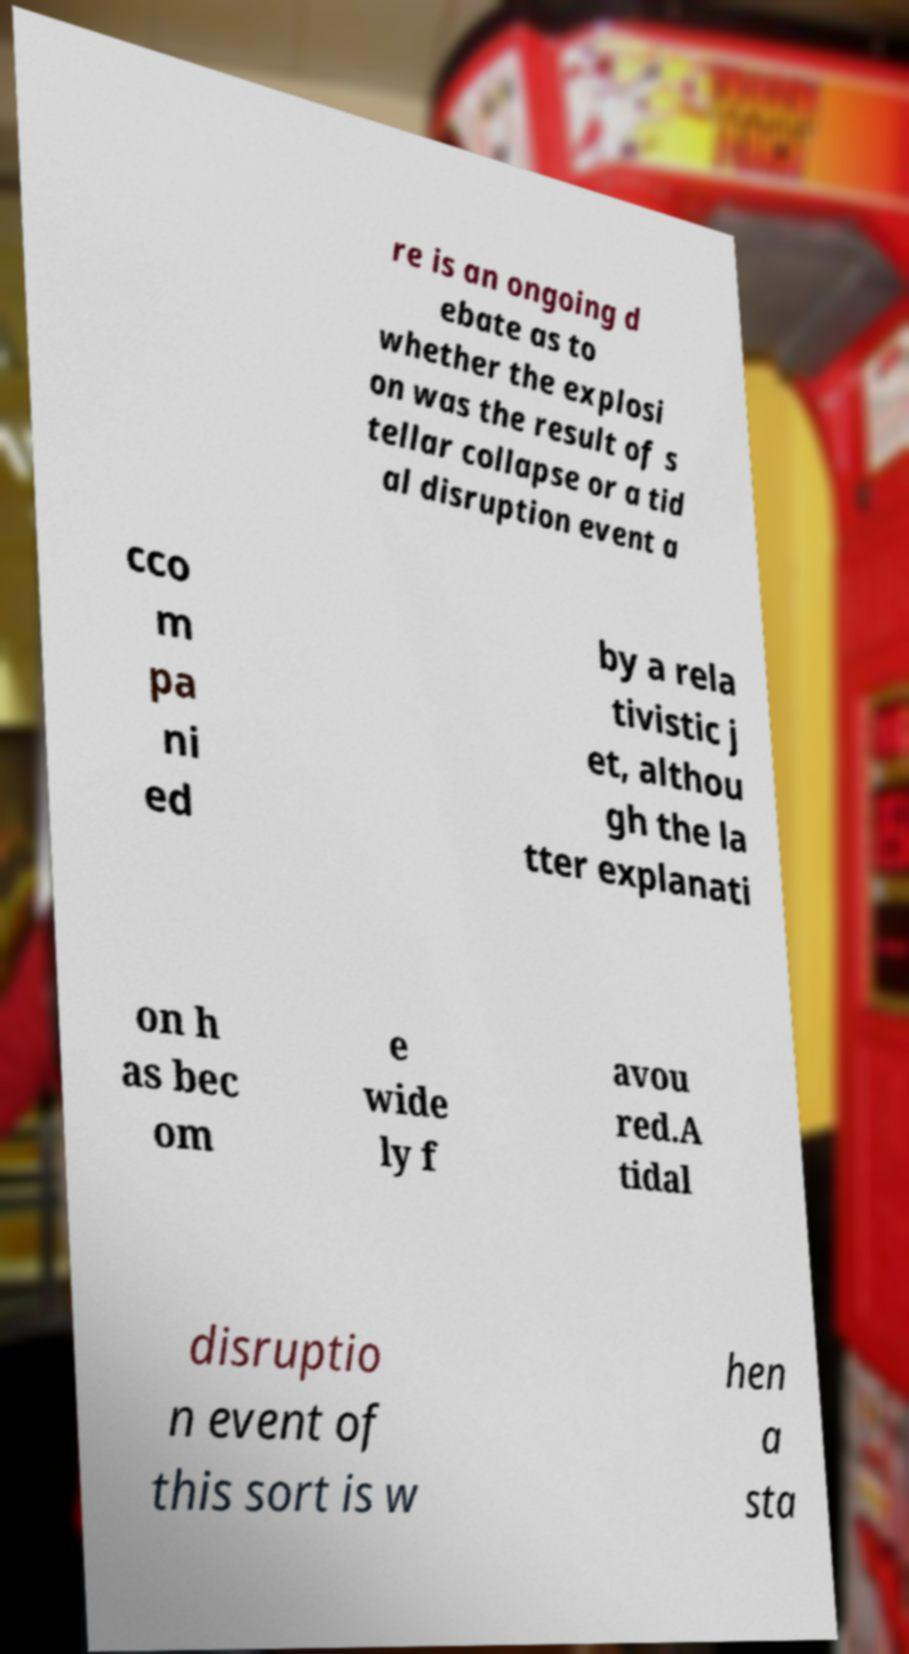Could you assist in decoding the text presented in this image and type it out clearly? re is an ongoing d ebate as to whether the explosi on was the result of s tellar collapse or a tid al disruption event a cco m pa ni ed by a rela tivistic j et, althou gh the la tter explanati on h as bec om e wide ly f avou red.A tidal disruptio n event of this sort is w hen a sta 